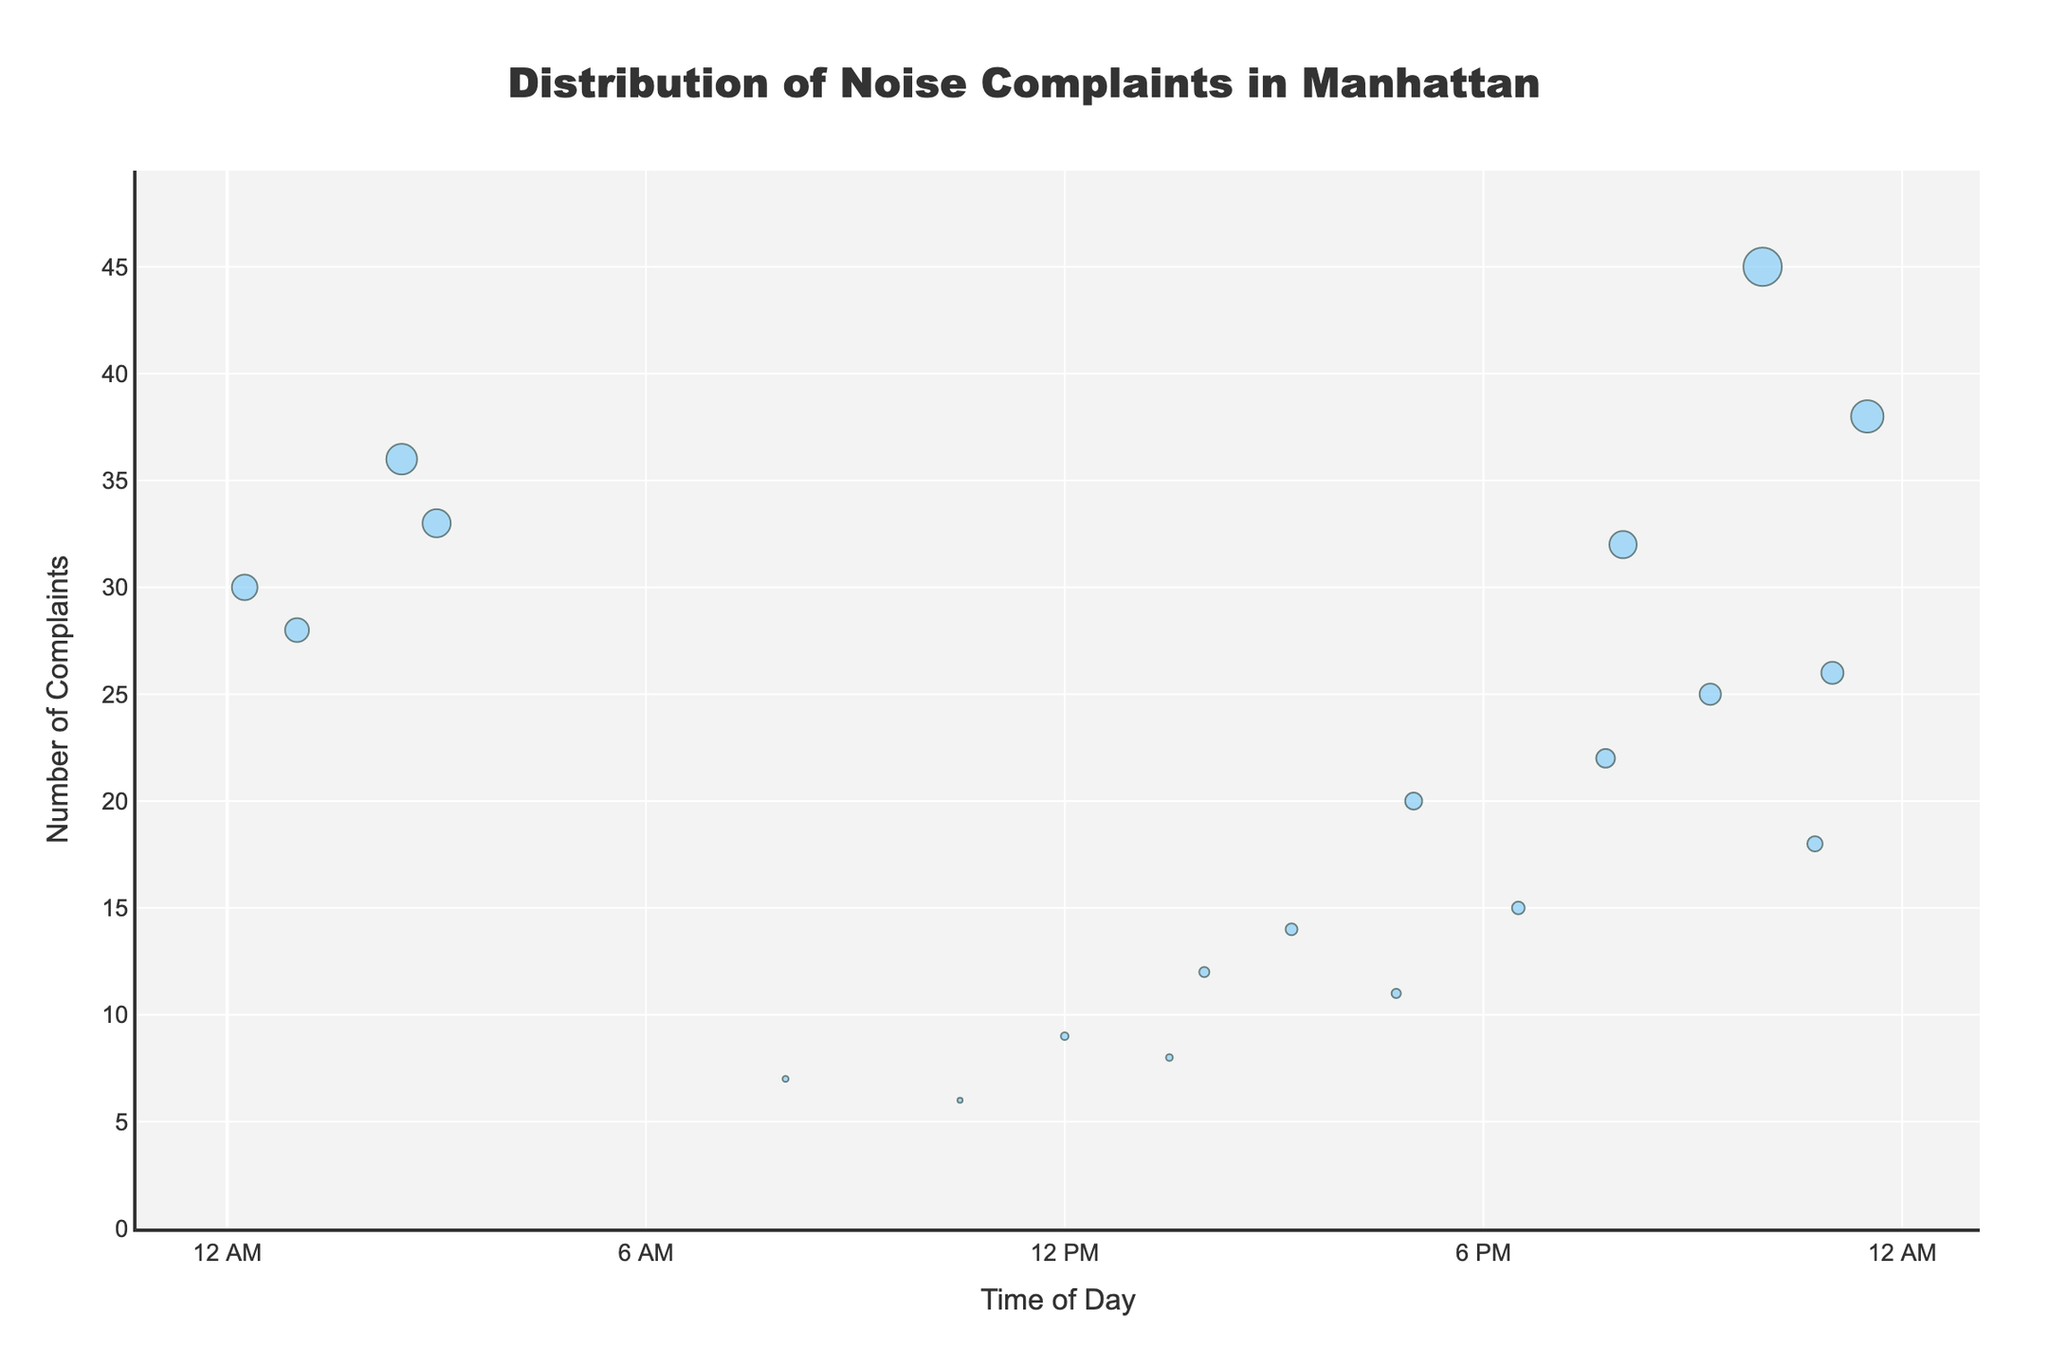What is the title of the plot? The title of the plot is displayed at the top of the figure and reads "Distribution of Noise Complaints in Manhattan".
Answer: Distribution of Noise Complaints in Manhattan During what time is the highest number of noise complaints recorded? The y-axis shows the number of complaints and the x-axis shows the time of day. The highest number of complaints is at 22:00 on Broadway in Midtown, with 45 complaints.
Answer: 22:00 Which district has the most complaints at the latest time of day shown on the plot? Checking the x-axis for the latest time and identifying the district with the highest complaints at that time, we find that at 23:30, the Theater District on West 42nd Street recorded 38 complaints.
Answer: Theater District How many complaints were recorded on East Houston Street in the Lower East Side? By looking at the hover text or through marking, we can see the complaints for East Houston Street. The number shown is 36 complaints.
Answer: 36 Which district had the fewest complaints? Comparing all the data points, we see that the fewest complaints are shown for Madison Avenue in Lenox Hill with a total of 6 complaints.
Answer: Lenox Hill What is the total number of complaints made before midday? By looking at the x-axis for times before 12 PM and summing up the related y-axis values, we find 9 (Canal Street) + 7 (Park Avenue) + 6 (Madison Avenue) = 22 complaints.
Answer: 22 Which two districts have a complaint count closest to each other? By examining the y-values' proximity, West 14th Street in Chelsea (20) and Riverside Drive in Morningside Heights (11) are closest, with a difference of 3 complaints only.
Answer: Chelsea and Morningside Heights What's the average number of complaints recorded in the East Village during the period displayed? For the East Village shown on Lexington Avenue at 20:00, the number of complaints is 32. Since there is only one data point, the average number of complaints is 32.
Answer: 32 What is the time range in the figure? The x-axis tick values show the time range from '12 AM' to '12 AM' of the next day.
Answer: 24 hours 